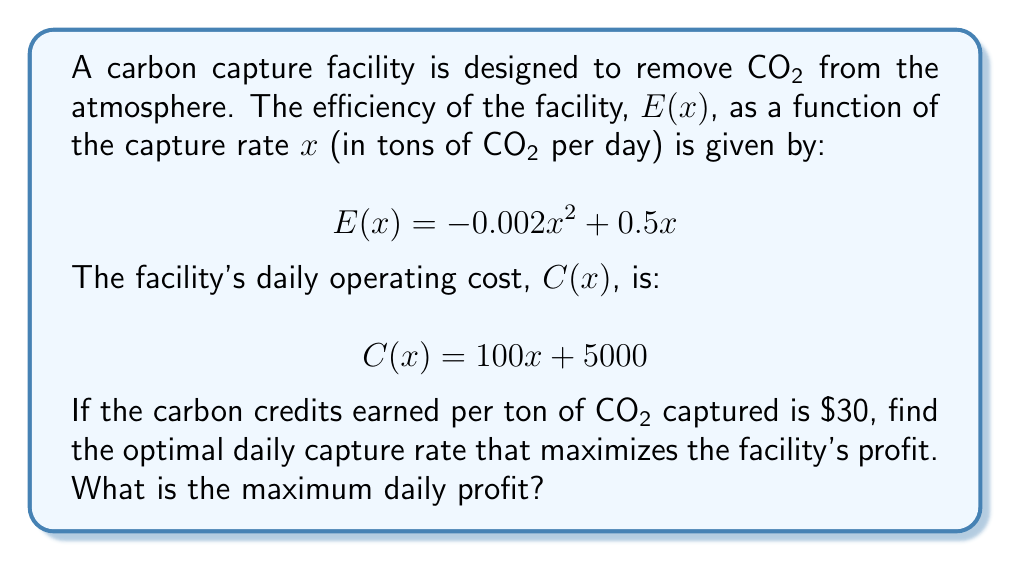Give your solution to this math problem. To solve this optimization problem, we need to follow these steps:

1. Define the profit function
2. Find the derivative of the profit function
3. Set the derivative to zero and solve for x
4. Verify it's a maximum using the second derivative test
5. Calculate the maximum profit

Step 1: Define the profit function
The daily profit, $P(x)$, is the difference between revenue and cost:
$$P(x) = 30E(x) - C(x)$$
Substituting the given functions:
$$P(x) = 30(-0.002x^2 + 0.5x) - (100x + 5000)$$
$$P(x) = -0.06x^2 + 15x - 100x - 5000$$
$$P(x) = -0.06x^2 - 85x - 5000$$

Step 2: Find the derivative of the profit function
$$P'(x) = -0.12x - 85$$

Step 3: Set the derivative to zero and solve for x
$$-0.12x - 85 = 0$$
$$-0.12x = 85$$
$$x = -\frac{85}{0.12} = -708.33$$

The negative value doesn't make sense in this context, so we'll also consider the endpoints of the domain. Since the capture rate can't be negative, the domain is [0, ∞).

Step 4: Verify it's a maximum using the second derivative test
$$P''(x) = -0.12$$
Since P''(x) is negative, any critical point would be a local maximum. However, we don't have any valid critical points in our domain.

Step 5: Calculate the maximum profit
Since there are no critical points in the domain, the maximum must occur at x = 0 or as x approaches infinity. Let's evaluate the profit function at x = 0 and as x approaches a very large number.

At x = 0:
$$P(0) = -0.06(0)^2 - 85(0) - 5000 = -5000$$

As x approaches infinity, the -0.06x^2 term will dominate, causing the profit to approach negative infinity.

Therefore, the maximum profit occurs at x = 0, which means the facility should not operate at all to minimize losses.
Answer: The optimal daily capture rate is 0 tons of CO₂ per day. The maximum daily profit (or minimum loss in this case) is $-5000. 